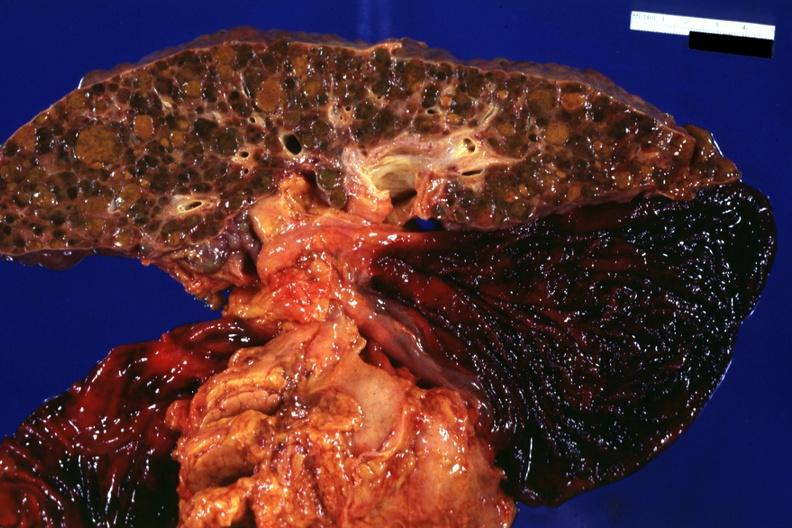what is present?
Answer the question using a single word or phrase. Hepatobiliary 